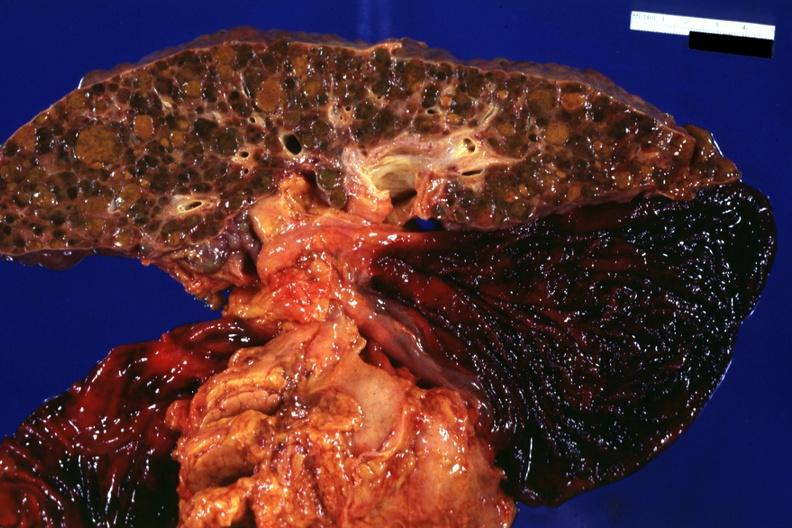what is present?
Answer the question using a single word or phrase. Hepatobiliary 